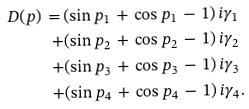Convert formula to latex. <formula><loc_0><loc_0><loc_500><loc_500>D ( p ) \, = \, & ( \sin p _ { 1 } \, + \, \cos p _ { 1 } \, - \, 1 ) \, i \gamma _ { 1 } \\ + & ( \sin p _ { 2 } \, + \, \cos p _ { 2 } \, - \, 1 ) \, i \gamma _ { 2 } \\ + & ( \sin p _ { 3 } \, + \, \cos p _ { 3 } \, - \, 1 ) \, i \gamma _ { 3 } \\ + & ( \sin p _ { 4 } \, + \, \cos p _ { 4 } \, - \, 1 ) \, i \gamma _ { 4 } .</formula> 